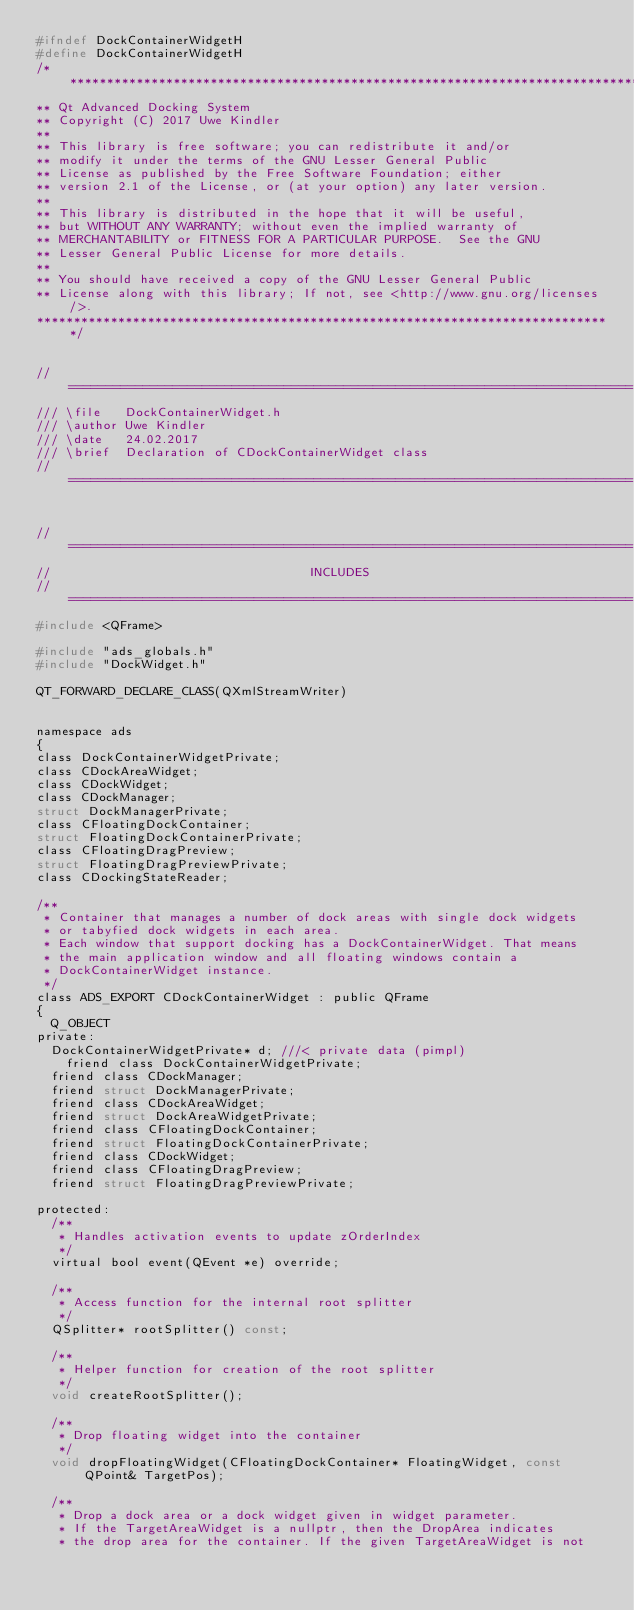Convert code to text. <code><loc_0><loc_0><loc_500><loc_500><_C_>#ifndef DockContainerWidgetH
#define DockContainerWidgetH
/*******************************************************************************
** Qt Advanced Docking System
** Copyright (C) 2017 Uwe Kindler
**
** This library is free software; you can redistribute it and/or
** modify it under the terms of the GNU Lesser General Public
** License as published by the Free Software Foundation; either
** version 2.1 of the License, or (at your option) any later version.
**
** This library is distributed in the hope that it will be useful,
** but WITHOUT ANY WARRANTY; without even the implied warranty of
** MERCHANTABILITY or FITNESS FOR A PARTICULAR PURPOSE.  See the GNU
** Lesser General Public License for more details.
**
** You should have received a copy of the GNU Lesser General Public
** License along with this library; If not, see <http://www.gnu.org/licenses/>.
******************************************************************************/


//============================================================================
/// \file   DockContainerWidget.h
/// \author Uwe Kindler
/// \date   24.02.2017
/// \brief  Declaration of CDockContainerWidget class
//============================================================================


//============================================================================
//                                   INCLUDES
//============================================================================
#include <QFrame>

#include "ads_globals.h"
#include "DockWidget.h"

QT_FORWARD_DECLARE_CLASS(QXmlStreamWriter)


namespace ads
{
class DockContainerWidgetPrivate;
class CDockAreaWidget;
class CDockWidget;
class CDockManager;
struct DockManagerPrivate;
class CFloatingDockContainer;
struct FloatingDockContainerPrivate;
class CFloatingDragPreview;
struct FloatingDragPreviewPrivate;
class CDockingStateReader;

/**
 * Container that manages a number of dock areas with single dock widgets
 * or tabyfied dock widgets in each area.
 * Each window that support docking has a DockContainerWidget. That means
 * the main application window and all floating windows contain a 
 * DockContainerWidget instance.
 */
class ADS_EXPORT CDockContainerWidget : public QFrame
{
	Q_OBJECT
private:
	DockContainerWidgetPrivate* d; ///< private data (pimpl)
    friend class DockContainerWidgetPrivate;
	friend class CDockManager;
	friend struct DockManagerPrivate;
	friend class CDockAreaWidget;
	friend struct DockAreaWidgetPrivate;
	friend class CFloatingDockContainer;
	friend struct FloatingDockContainerPrivate;
	friend class CDockWidget;
	friend class CFloatingDragPreview;
	friend struct FloatingDragPreviewPrivate;

protected:
	/**
	 * Handles activation events to update zOrderIndex
	 */
	virtual bool event(QEvent *e) override;

	/**
	 * Access function for the internal root splitter
	 */
	QSplitter* rootSplitter() const;

	/**
	 * Helper function for creation of the root splitter
	 */
	void createRootSplitter();

	/**
	 * Drop floating widget into the container
	 */
	void dropFloatingWidget(CFloatingDockContainer* FloatingWidget, const QPoint& TargetPos);

	/**
	 * Drop a dock area or a dock widget given in widget parameter.
	 * If the TargetAreaWidget is a nullptr, then the DropArea indicates
	 * the drop area for the container. If the given TargetAreaWidget is not</code> 